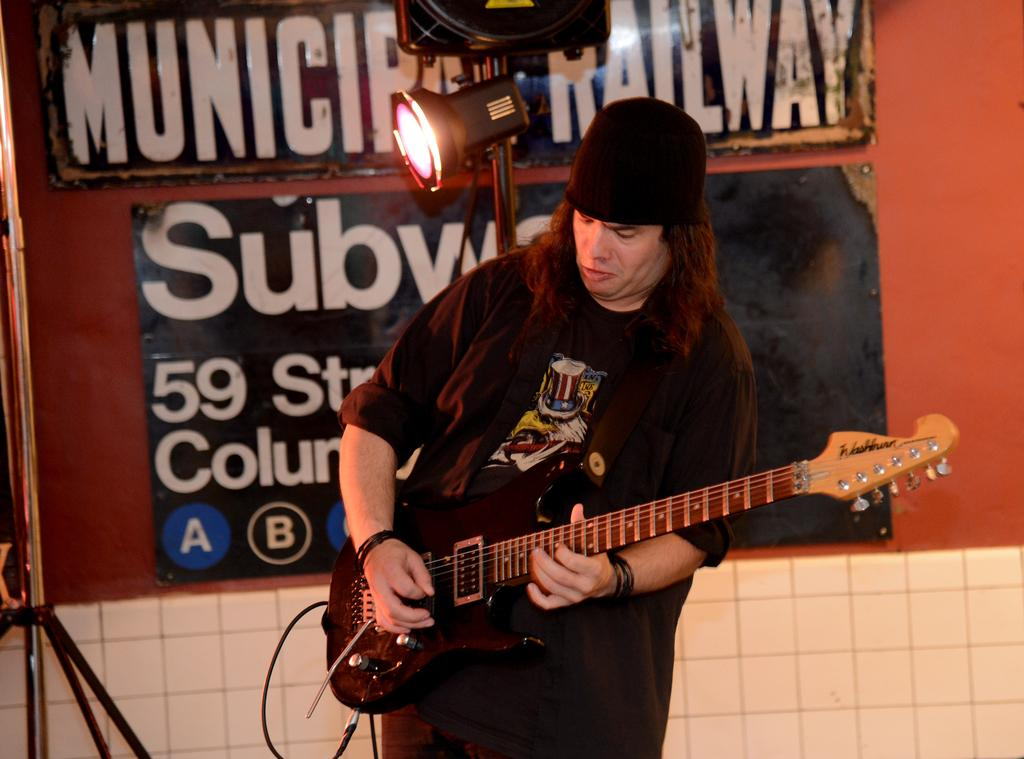What is the man in the image wearing? The man is wearing a black cap and a black dress. What is the man doing in the image? The man is playing a guitar. What can be seen in the background of the image? There is a red wall with two boards in the background. What is the source of light in the image? There is a light attached to a stand behind the man. Can you tell me how many spades are visible in the image? There are no spades present in the image. What type of pet is sitting next to the man in the image? There is no pet present in the image; it only features the man playing a guitar. 